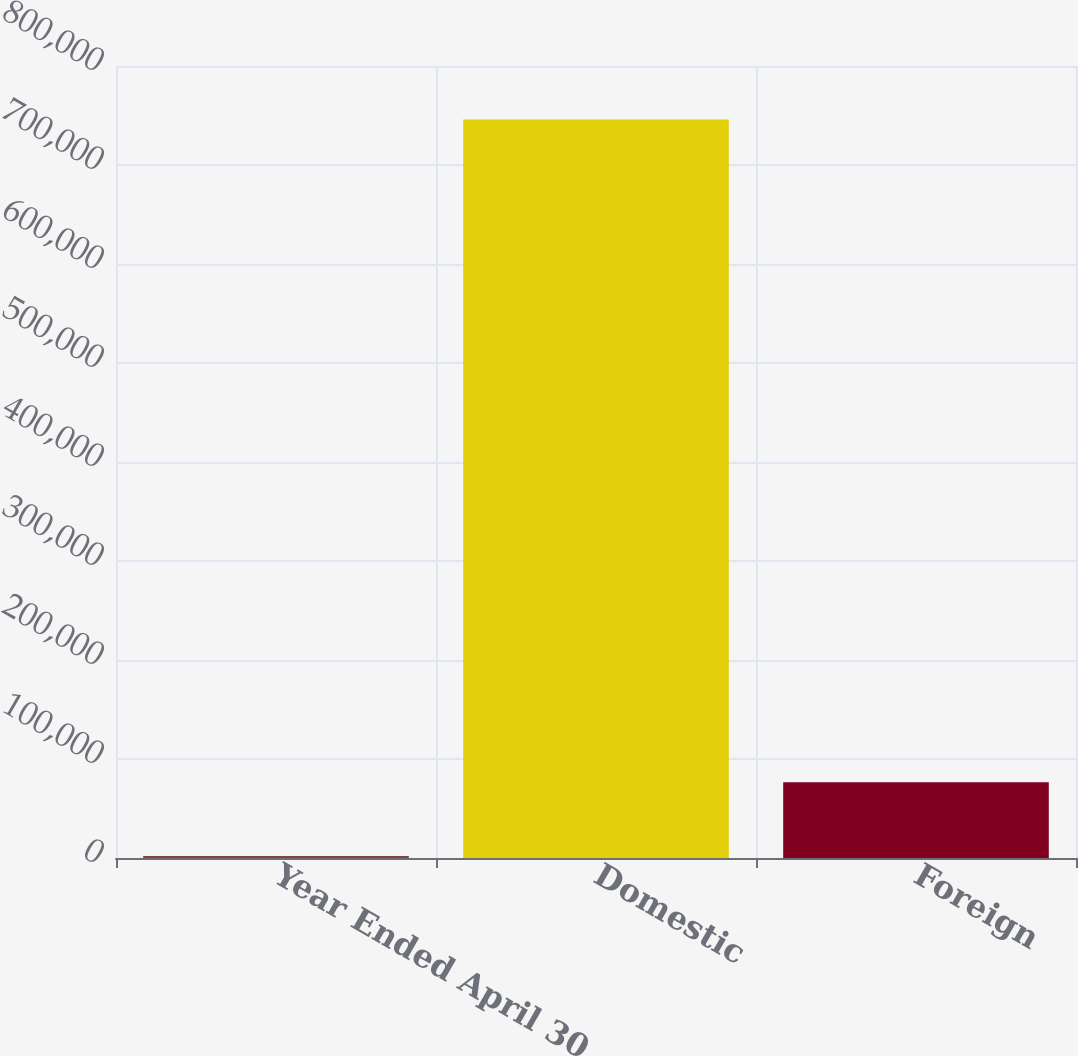<chart> <loc_0><loc_0><loc_500><loc_500><bar_chart><fcel>Year Ended April 30<fcel>Domestic<fcel>Foreign<nl><fcel>2010<fcel>745912<fcel>76400.2<nl></chart> 